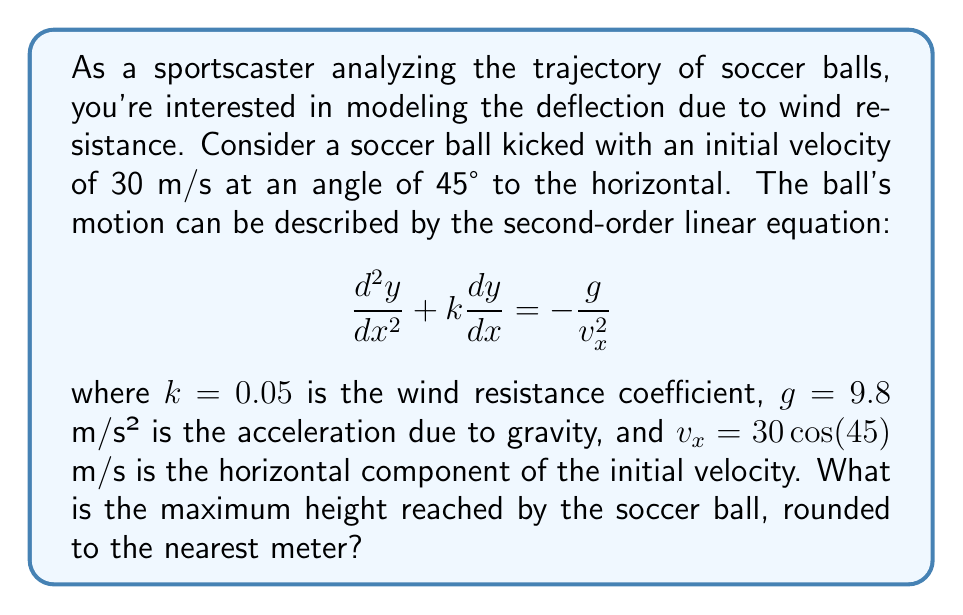Could you help me with this problem? To solve this problem, we need to follow these steps:

1) First, we need to solve the second-order linear equation. The general solution is:

   $$y = C_1 + C_2e^{-kx} - \frac{g}{kv_x^2}x$$

2) To find $C_1$ and $C_2$, we use the initial conditions:
   At $x = 0$, $y = 0$ and $\frac{dy}{dx} = \tan(45°) = 1$

3) Applying the first condition:
   
   $$0 = C_1 + C_2 - 0$$
   $$C_1 = -C_2$$

4) For the second condition, we differentiate $y$ with respect to $x$:

   $$\frac{dy}{dx} = -kC_2e^{-kx} - \frac{g}{kv_x^2}$$

   At $x = 0$, this should equal 1:

   $$1 = -kC_2 - \frac{g}{kv_x^2}$$

5) Solving for $C_2$:

   $$C_2 = -\frac{1}{k} - \frac{g}{k^2v_x^2} = -\frac{1}{0.05} - \frac{9.8}{(0.05)^2(30\cos(45°))^2} \approx -20 - 784.53 = -804.53$$

6) Therefore, $C_1 = 804.53$

7) The trajectory equation becomes:

   $$y = 804.53 - 804.53e^{-0.05x} - \frac{9.8}{0.05(30\cos(45°))^2}x$$

8) To find the maximum height, we need to find where $\frac{dy}{dx} = 0$:

   $$0 = 40.2265e^{-0.05x} - 0.3919$$

   Solving this:

   $$x = \frac{\ln(0.3919/40.2265)}{-0.05} \approx 92.3 \text{ m}$$

9) Plugging this $x$ value back into our $y$ equation:

   $$y_{max} = 804.53 - 804.53e^{-0.05(92.3)} - \frac{9.8}{0.05(30\cos(45°))^2}(92.3) \approx 51.7 \text{ m}$$
Answer: The maximum height reached by the soccer ball, rounded to the nearest meter, is 52 m. 